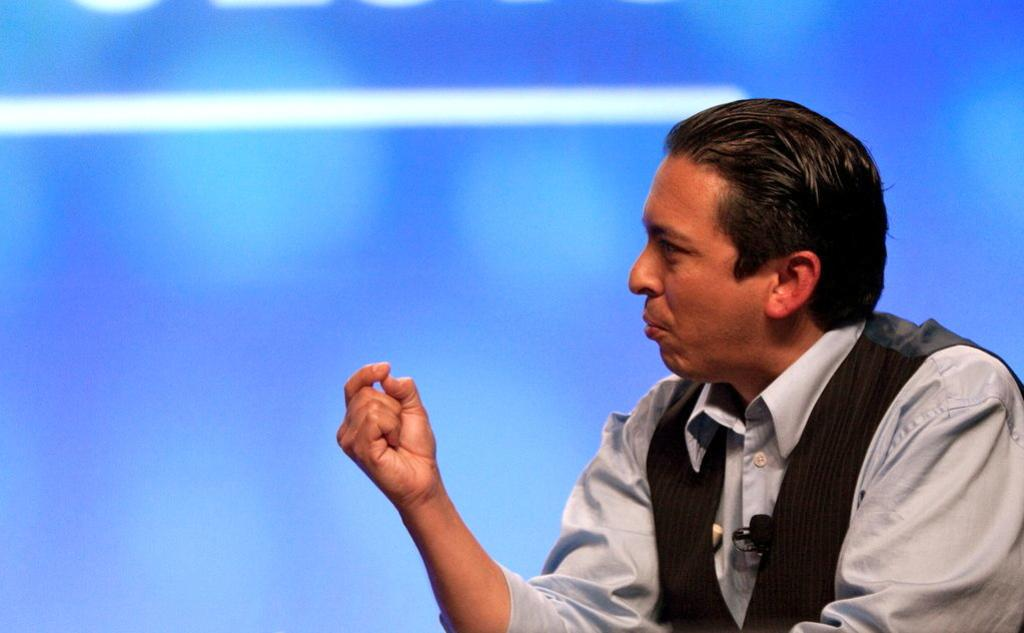Who is present in the image? There is a man in the image. What is the man wearing? The man is wearing a formal dress. What colors are present in the man's formal dress? The formal dress is white and blue in color. What is the color of the background in the image? The background of the image is white and blue. How does the man sort the items on the table in the image? There is no table or items present in the image; it only features a man wearing a formal dress. Can you spot the comb in the man's hair in the image? There is no comb visible in the man's hair in the image. 